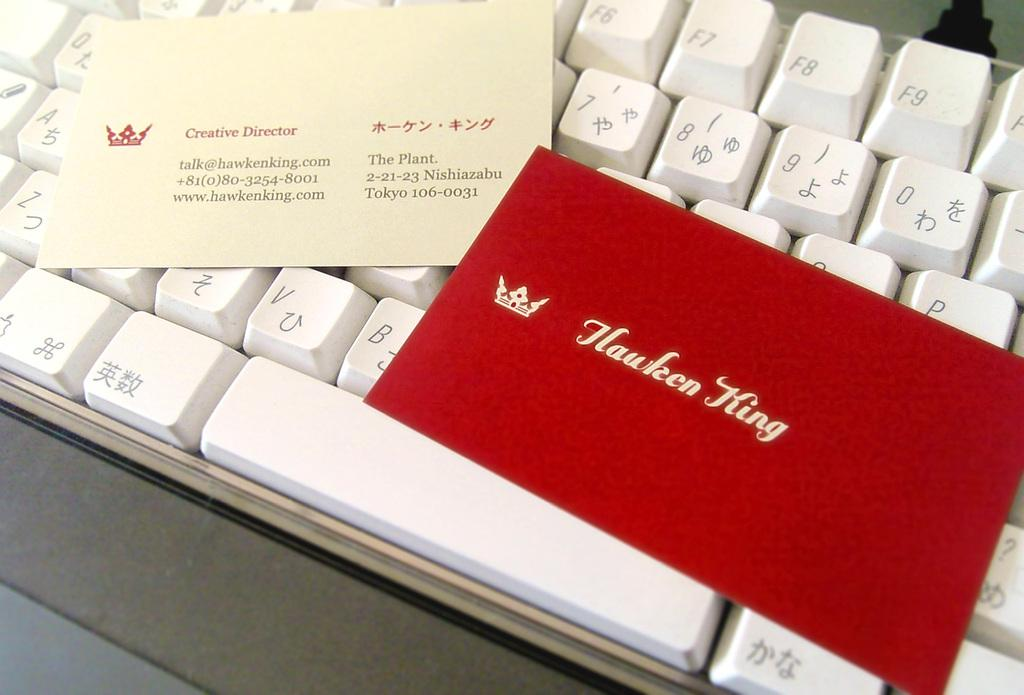What objects are placed on the keyboard in the image? There are cards on the keyboard in the image. What type of locket is hanging from the cards on the keyboard in the image? There is no locket present in the image; only cards are placed on the keyboard. 